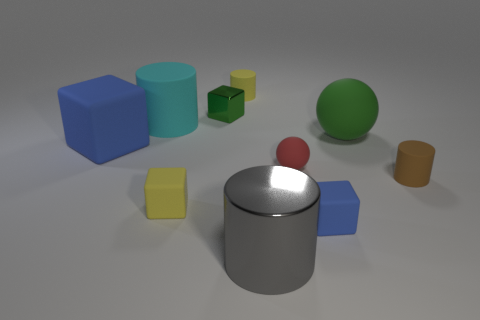What is the size of the yellow matte object in front of the green sphere?
Offer a terse response. Small. What number of big objects are blue metal spheres or blue rubber things?
Your answer should be compact. 1. There is a cylinder that is to the right of the green shiny object and behind the large ball; what is its color?
Offer a very short reply. Yellow. Are there any small metallic things that have the same shape as the small brown rubber thing?
Ensure brevity in your answer.  No. What material is the big cyan cylinder?
Make the answer very short. Rubber. Are there any small yellow rubber blocks right of the tiny blue block?
Offer a terse response. No. Is the shape of the big green matte object the same as the red matte object?
Ensure brevity in your answer.  Yes. What number of other things are there of the same size as the green sphere?
Make the answer very short. 3. How many things are rubber cylinders that are to the left of the large green rubber thing or tiny blue rubber cubes?
Your answer should be very brief. 3. The large metal cylinder is what color?
Offer a terse response. Gray. 